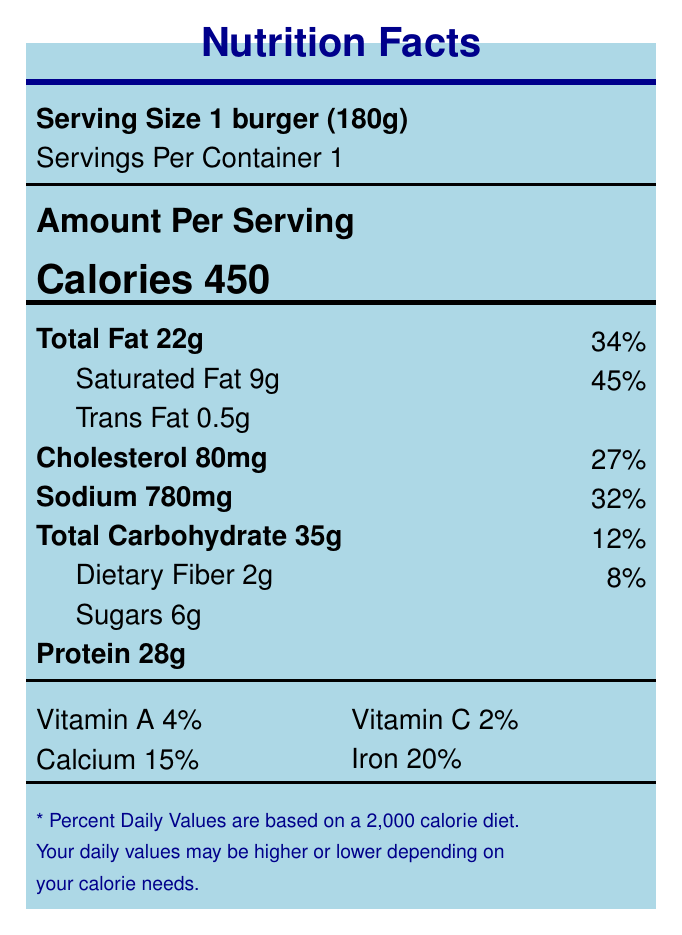how many calories are in a serving of the Classic Cheeseburger? The document states that a serving size of the Classic Cheeseburger contains 450 calories.
Answer: 450 what is the percentage of daily value for saturated fat in the Classic Cheeseburger? The nutrient table lists the saturated fat content as 9g, which represents 45% of the daily value.
Answer: 45% how much protein does the Classic Cheeseburger provide? According to the document, the Classic Cheeseburger contains 28g of protein.
Answer: 28g what is the serving size of the Classic Cheeseburger? The serving size is specified as 1 burger (180g) in the document.
Answer: 1 burger (180g) what is the total carbohydrate content in the Classic Cheeseburger? The total carbohydrate content of the Classic Cheeseburger is listed as 35g in the nutrient table.
Answer: 35g what are the percent daily values for vitamin A and vitamin C? A. Vitamin A 6%, Vitamin C 2% B. Vitamin A 4%, Vitamin C 2% C. Vitamin A 4%, Vitamin C 8% D. Vitamin A 6%, Vitamin C 8% The document lists the daily values as Vitamin A 4% and Vitamin C 2%.
Answer: B which nutrient has the highest daily value percentage in the Classic Cheeseburger? A. Total Fat B. Saturated Fat C. Sodium D. Protein Saturated Fat has the highest daily value percentage at 45%.
Answer: B is trans fat content shown on the nutrition facts label? The document specifies the trans fat content as 0.5g.
Answer: Yes summarize the nutrition facts of the Classic Cheeseburger. This summary consolidates the key nutritional components, including macronutrients, vitamins, and minerals, as listed in the document.
Answer: The Classic Cheeseburger contains 450 calories per serving (1 burger, 180g), with 22g of total fat, 9g of saturated fat, 0.5g of trans fat, 80mg of cholesterol, 780mg of sodium, 35g of carbohydrates, 2g of dietary fiber, 6g of sugars, and 28g of protein. It also includes 4% of the daily value for vitamin A, 2% for vitamin C, 15% for calcium, and 20% for iron. what is the economic impact of Joe's Burgers on local job creation? The document does not provide specific data on the economic impact of Joe's Burgers on local job creation; the details are only in aggregate for independent eateries and chain restaurants.
Answer: Not enough information 